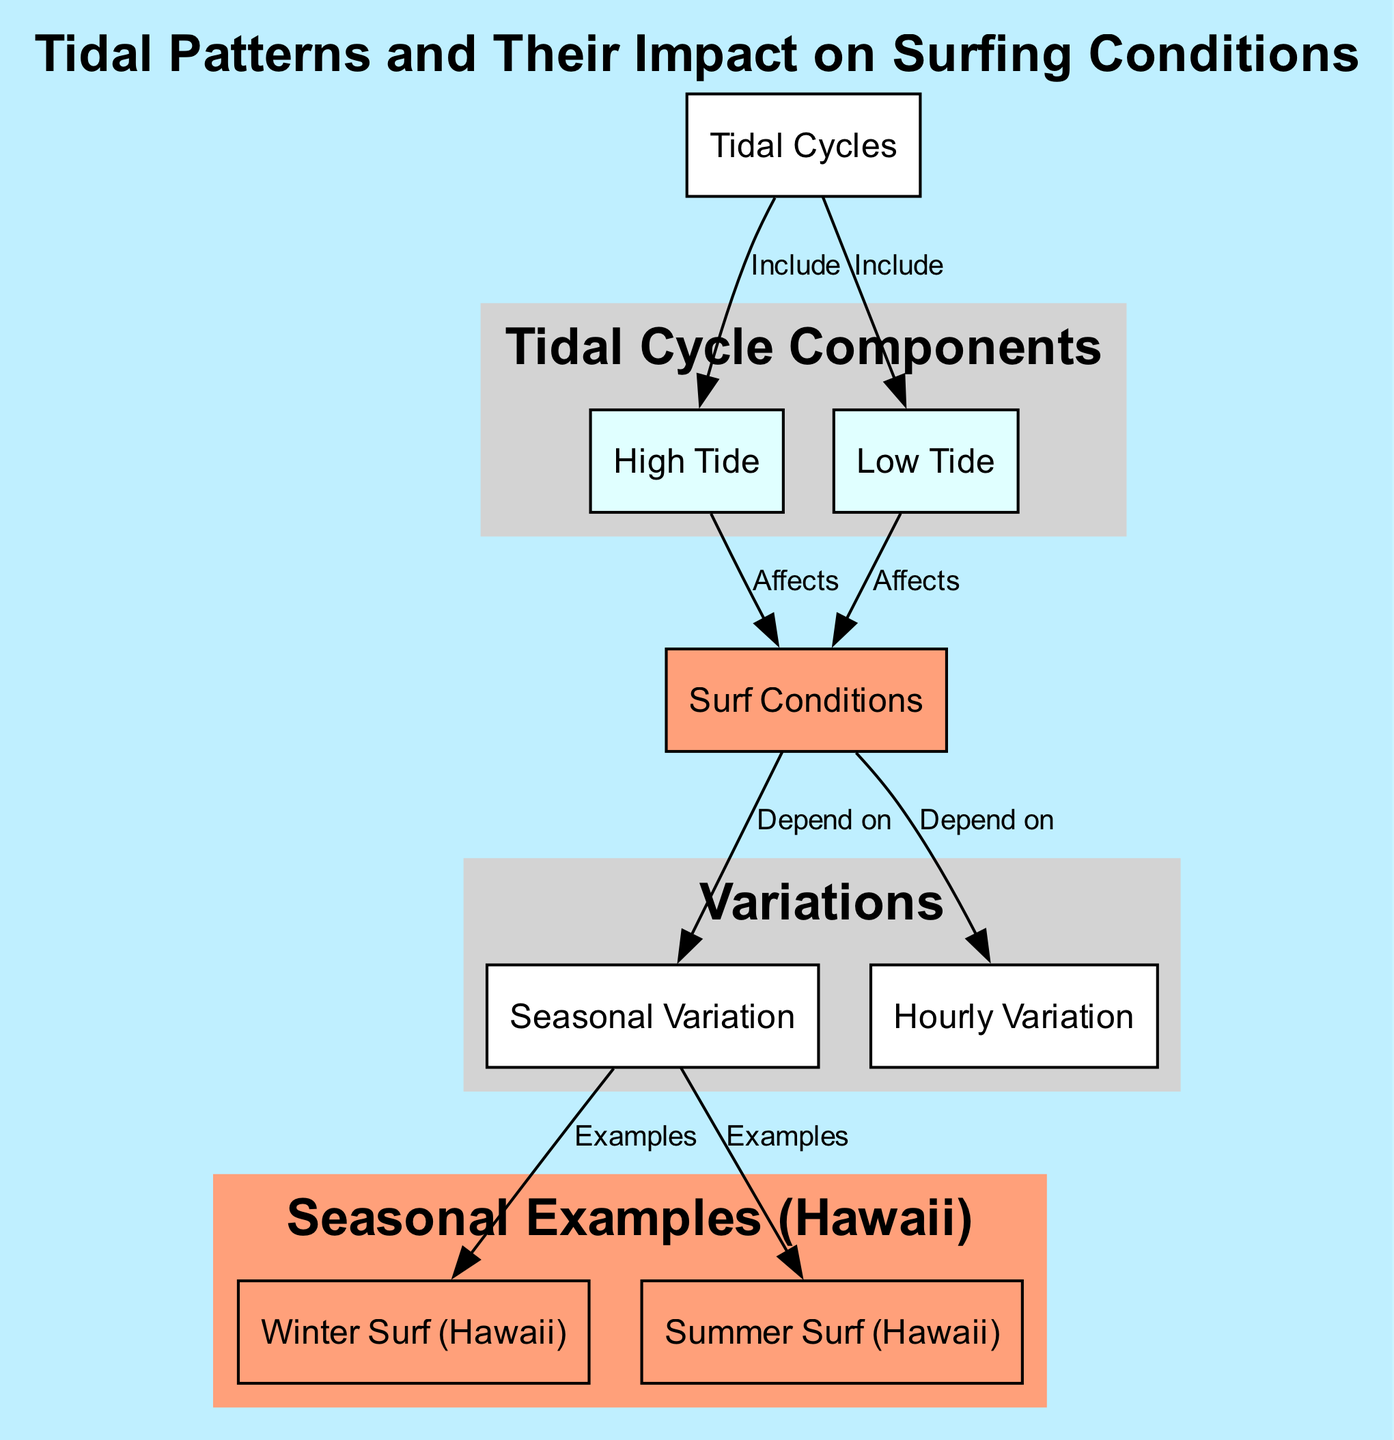What are the two components of tidal cycles? The diagram indicates that the components of tidal cycles are high tide and low tide, which are both directly connected to the tidal cycles node.
Answer: high tide, low tide How does high tide affect surf conditions? The diagram shows a directed edge from high tide to surf conditions, indicating that high tide has a direct impact on surf conditions.
Answer: Affects What examples are given for seasonal variation in surfing? From the seasonal variation node, the diagram provides two examples that branch out: winter surf and summer surf, suggesting variations based on the seasons.
Answer: winter surf, summer surf How many nodes represent different seasons of surfing? In the diagram, there are two nodes that specifically represent the seasons of surfing - winter surf and summer surf. This can be counted directly from the seasonal variation connections.
Answer: 2 What does low tide do to surf conditions? The low tide node has a directed edge towards surf conditions in the diagram, showing a direct relationship. This indicates that low tide also affects surf conditions just like high tide.
Answer: Affects Which variation depends on the time of day? The diagram connects hourly variation to surf conditions, specifying that surf conditions vary depending on the time of day. Thus, this highlights hourly variation as a crucial factor.
Answer: Hourly Variation How many edges are present in the diagram? Counting the edges illustrated in the diagram (connections between nodes), there are a total of eight edges, representing the relationships between the various nodes.
Answer: 8 What is the relationship between seasonal variation and surf conditions? The diagram shows a directional relationship where surf conditions depend on seasonal variation, indicating seasonal differences affect surfing experiences.
Answer: Depend on What node is associated with winter surf? The diagram clearly links the winter surf node to seasonal variation, highlighting that winter surf serves as an example of seasonal variations in surf conditions.
Answer: seasonal variation 